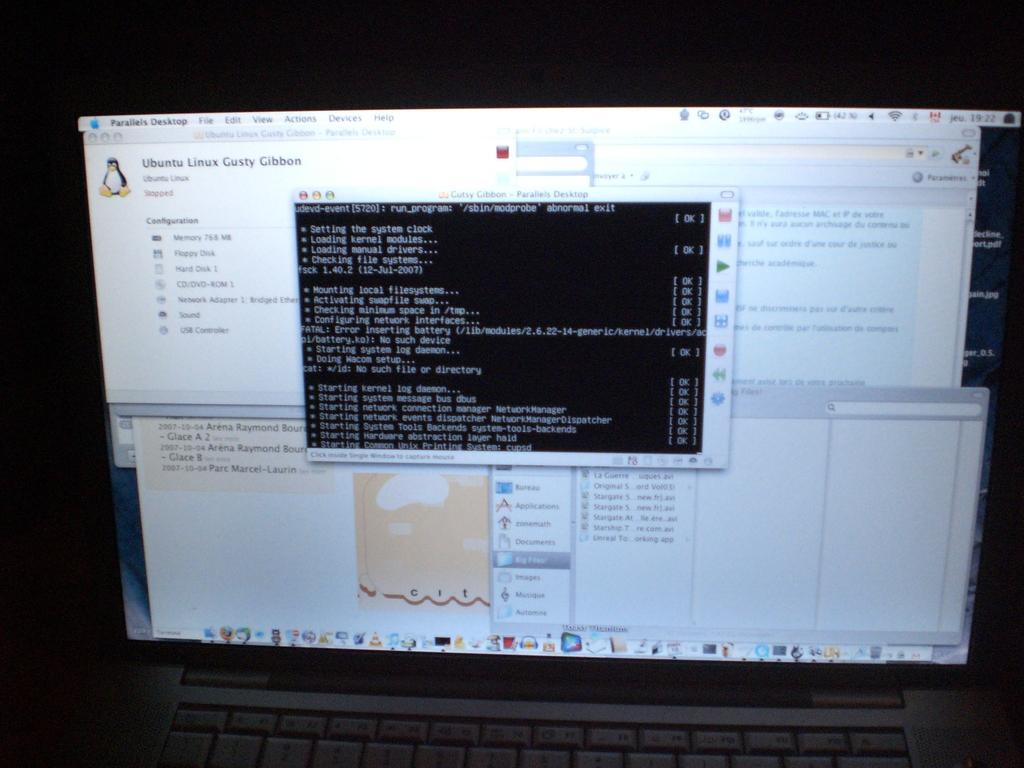<image>
Write a terse but informative summary of the picture. Computer screen that has a popup that says Ubuntu Linux. 